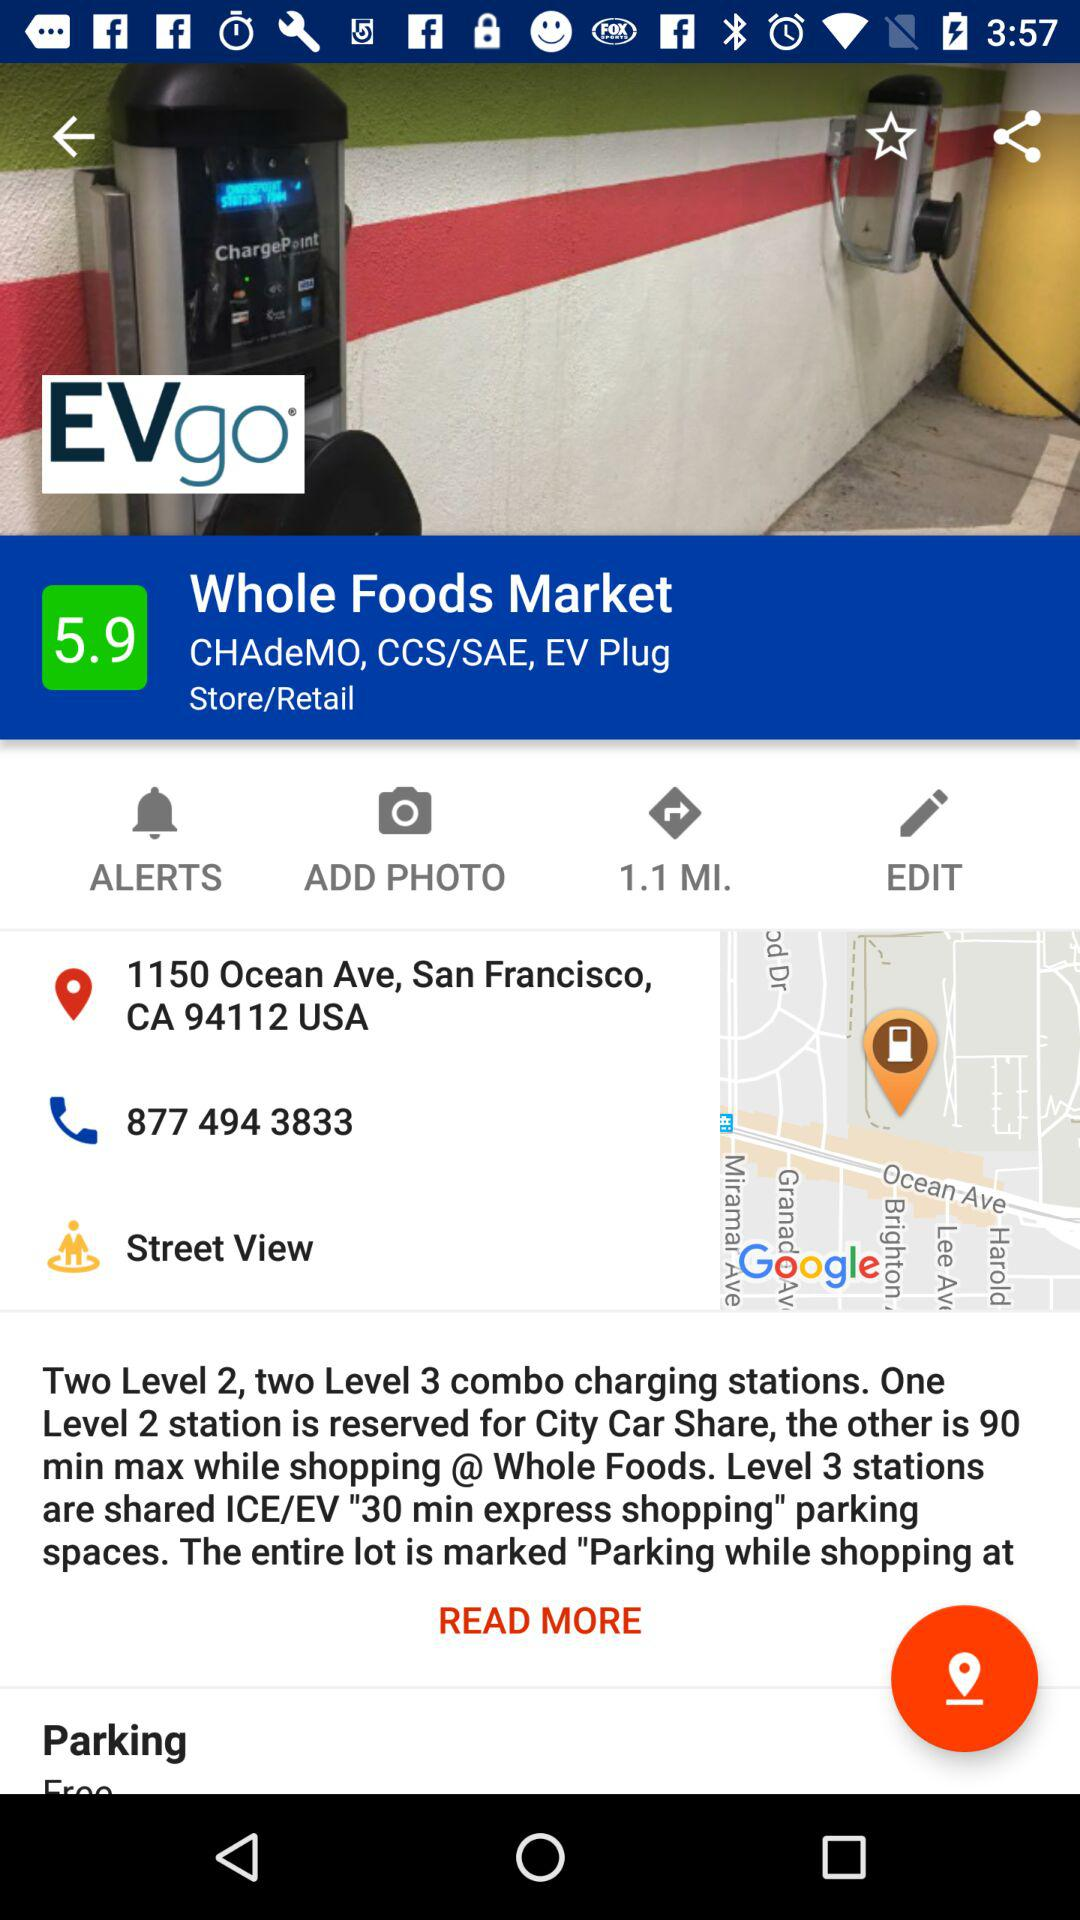How many Level 3 stations are there?
Answer the question using a single word or phrase. 2 